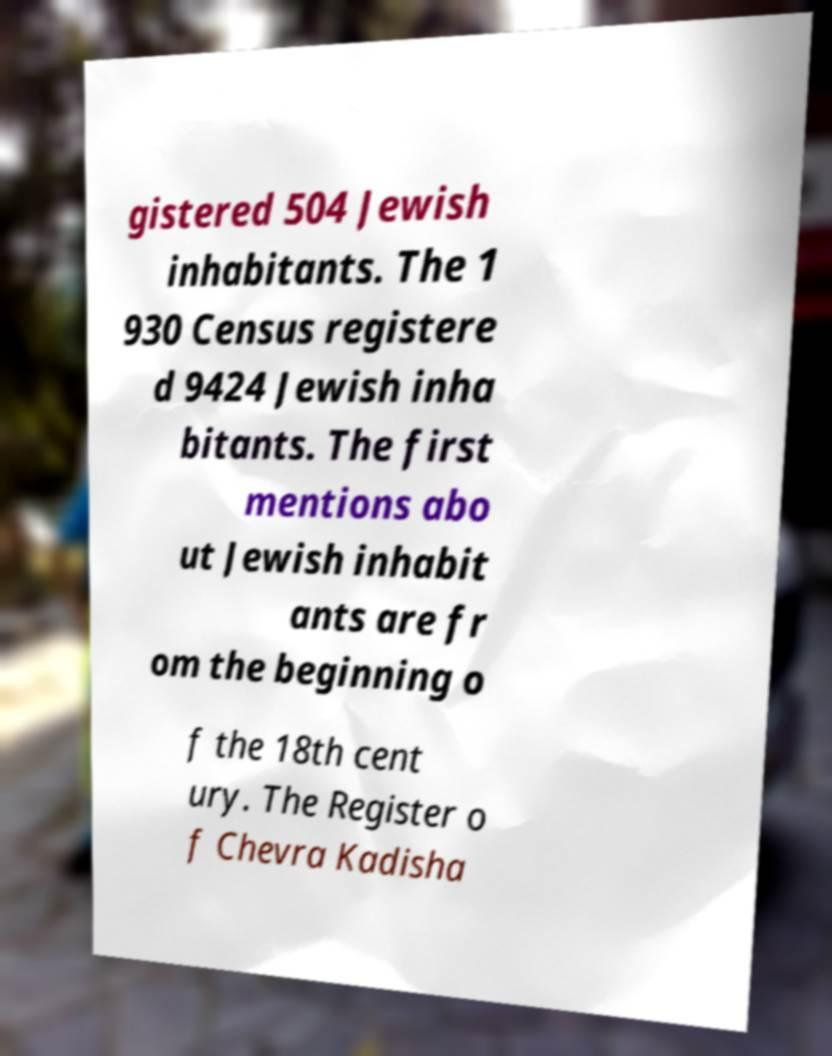Please identify and transcribe the text found in this image. gistered 504 Jewish inhabitants. The 1 930 Census registere d 9424 Jewish inha bitants. The first mentions abo ut Jewish inhabit ants are fr om the beginning o f the 18th cent ury. The Register o f Chevra Kadisha 